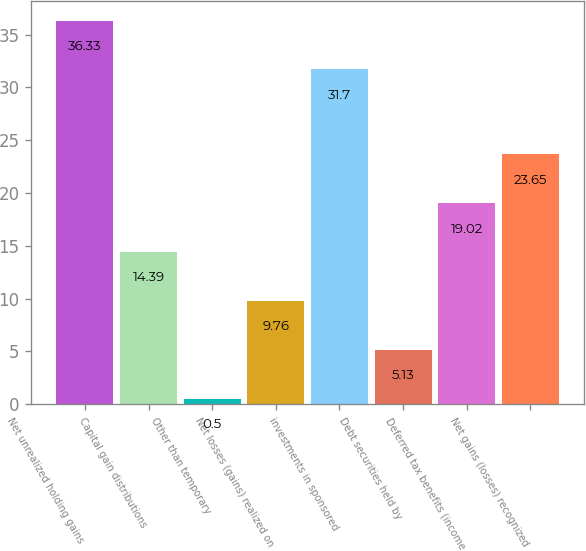Convert chart to OTSL. <chart><loc_0><loc_0><loc_500><loc_500><bar_chart><fcel>Net unrealized holding gains<fcel>Capital gain distributions<fcel>Other than temporary<fcel>Net losses (gains) realized on<fcel>investments in sponsored<fcel>Debt securities held by<fcel>Deferred tax benefits (income<fcel>Net gains (losses) recognized<nl><fcel>36.33<fcel>14.39<fcel>0.5<fcel>9.76<fcel>31.7<fcel>5.13<fcel>19.02<fcel>23.65<nl></chart> 